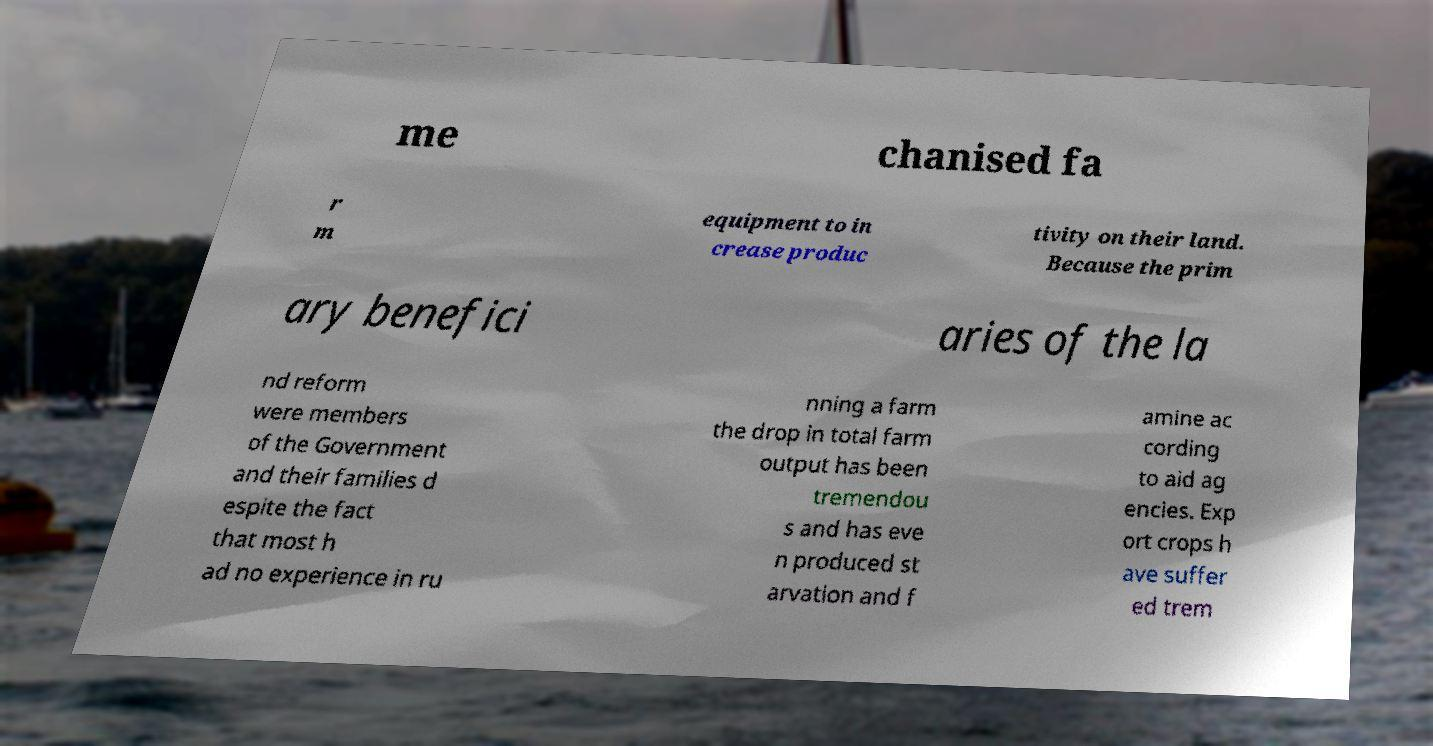Please identify and transcribe the text found in this image. me chanised fa r m equipment to in crease produc tivity on their land. Because the prim ary benefici aries of the la nd reform were members of the Government and their families d espite the fact that most h ad no experience in ru nning a farm the drop in total farm output has been tremendou s and has eve n produced st arvation and f amine ac cording to aid ag encies. Exp ort crops h ave suffer ed trem 